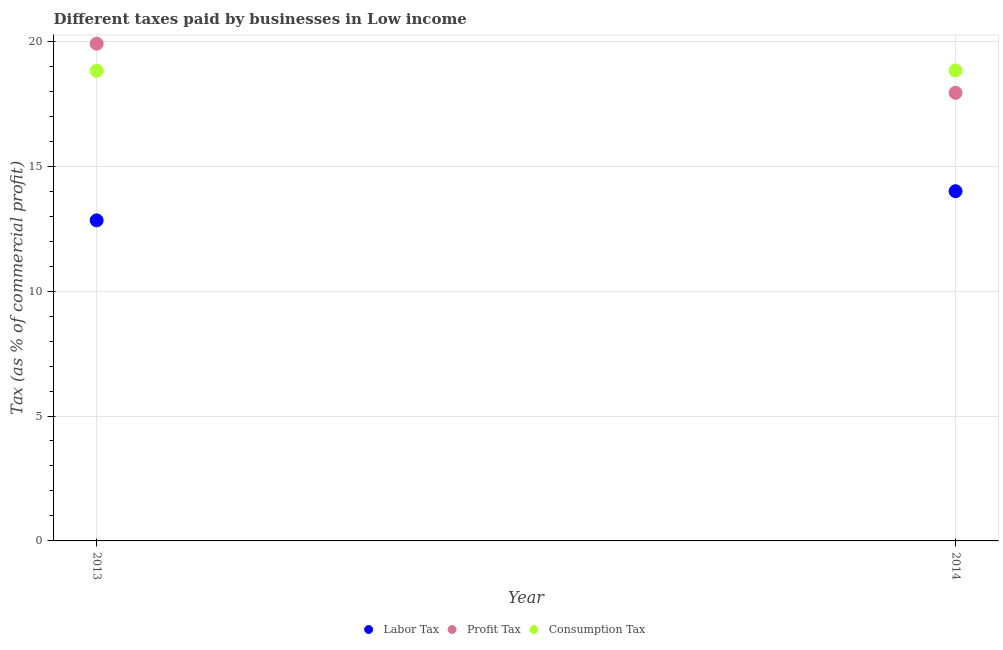How many different coloured dotlines are there?
Your answer should be very brief. 3. Is the number of dotlines equal to the number of legend labels?
Your answer should be very brief. Yes. What is the percentage of consumption tax in 2013?
Your answer should be very brief. 18.82. Across all years, what is the maximum percentage of profit tax?
Provide a succinct answer. 19.9. Across all years, what is the minimum percentage of profit tax?
Your response must be concise. 17.94. In which year was the percentage of labor tax maximum?
Your answer should be compact. 2014. What is the total percentage of labor tax in the graph?
Provide a succinct answer. 26.83. What is the difference between the percentage of consumption tax in 2013 and that in 2014?
Your answer should be very brief. -0.01. What is the difference between the percentage of consumption tax in 2014 and the percentage of profit tax in 2013?
Provide a succinct answer. -1.07. What is the average percentage of consumption tax per year?
Offer a terse response. 18.83. In the year 2014, what is the difference between the percentage of profit tax and percentage of labor tax?
Your answer should be very brief. 3.94. What is the ratio of the percentage of labor tax in 2013 to that in 2014?
Make the answer very short. 0.92. Does the percentage of labor tax monotonically increase over the years?
Offer a terse response. Yes. Is the percentage of profit tax strictly greater than the percentage of labor tax over the years?
Your response must be concise. Yes. How many years are there in the graph?
Provide a succinct answer. 2. What is the difference between two consecutive major ticks on the Y-axis?
Give a very brief answer. 5. Does the graph contain any zero values?
Your response must be concise. No. Where does the legend appear in the graph?
Provide a succinct answer. Bottom center. What is the title of the graph?
Offer a very short reply. Different taxes paid by businesses in Low income. What is the label or title of the Y-axis?
Offer a terse response. Tax (as % of commercial profit). What is the Tax (as % of commercial profit) in Labor Tax in 2013?
Provide a succinct answer. 12.83. What is the Tax (as % of commercial profit) in Profit Tax in 2013?
Provide a succinct answer. 19.9. What is the Tax (as % of commercial profit) in Consumption Tax in 2013?
Provide a succinct answer. 18.82. What is the Tax (as % of commercial profit) of Profit Tax in 2014?
Give a very brief answer. 17.94. What is the Tax (as % of commercial profit) of Consumption Tax in 2014?
Provide a short and direct response. 18.83. Across all years, what is the maximum Tax (as % of commercial profit) of Profit Tax?
Provide a short and direct response. 19.9. Across all years, what is the maximum Tax (as % of commercial profit) in Consumption Tax?
Make the answer very short. 18.83. Across all years, what is the minimum Tax (as % of commercial profit) of Labor Tax?
Make the answer very short. 12.83. Across all years, what is the minimum Tax (as % of commercial profit) of Profit Tax?
Your answer should be compact. 17.94. Across all years, what is the minimum Tax (as % of commercial profit) of Consumption Tax?
Your answer should be very brief. 18.82. What is the total Tax (as % of commercial profit) of Labor Tax in the graph?
Give a very brief answer. 26.83. What is the total Tax (as % of commercial profit) of Profit Tax in the graph?
Provide a short and direct response. 37.84. What is the total Tax (as % of commercial profit) in Consumption Tax in the graph?
Ensure brevity in your answer.  37.66. What is the difference between the Tax (as % of commercial profit) in Labor Tax in 2013 and that in 2014?
Your response must be concise. -1.17. What is the difference between the Tax (as % of commercial profit) of Profit Tax in 2013 and that in 2014?
Offer a very short reply. 1.97. What is the difference between the Tax (as % of commercial profit) of Consumption Tax in 2013 and that in 2014?
Give a very brief answer. -0.01. What is the difference between the Tax (as % of commercial profit) of Labor Tax in 2013 and the Tax (as % of commercial profit) of Profit Tax in 2014?
Your answer should be compact. -5.11. What is the difference between the Tax (as % of commercial profit) of Labor Tax in 2013 and the Tax (as % of commercial profit) of Consumption Tax in 2014?
Offer a very short reply. -6. What is the difference between the Tax (as % of commercial profit) of Profit Tax in 2013 and the Tax (as % of commercial profit) of Consumption Tax in 2014?
Your answer should be very brief. 1.07. What is the average Tax (as % of commercial profit) in Labor Tax per year?
Provide a short and direct response. 13.42. What is the average Tax (as % of commercial profit) in Profit Tax per year?
Provide a short and direct response. 18.92. What is the average Tax (as % of commercial profit) of Consumption Tax per year?
Provide a succinct answer. 18.83. In the year 2013, what is the difference between the Tax (as % of commercial profit) of Labor Tax and Tax (as % of commercial profit) of Profit Tax?
Offer a terse response. -7.07. In the year 2013, what is the difference between the Tax (as % of commercial profit) of Labor Tax and Tax (as % of commercial profit) of Consumption Tax?
Offer a terse response. -5.99. In the year 2013, what is the difference between the Tax (as % of commercial profit) in Profit Tax and Tax (as % of commercial profit) in Consumption Tax?
Give a very brief answer. 1.08. In the year 2014, what is the difference between the Tax (as % of commercial profit) in Labor Tax and Tax (as % of commercial profit) in Profit Tax?
Keep it short and to the point. -3.94. In the year 2014, what is the difference between the Tax (as % of commercial profit) of Labor Tax and Tax (as % of commercial profit) of Consumption Tax?
Keep it short and to the point. -4.83. In the year 2014, what is the difference between the Tax (as % of commercial profit) in Profit Tax and Tax (as % of commercial profit) in Consumption Tax?
Keep it short and to the point. -0.9. What is the ratio of the Tax (as % of commercial profit) in Labor Tax in 2013 to that in 2014?
Ensure brevity in your answer.  0.92. What is the ratio of the Tax (as % of commercial profit) in Profit Tax in 2013 to that in 2014?
Provide a succinct answer. 1.11. What is the ratio of the Tax (as % of commercial profit) in Consumption Tax in 2013 to that in 2014?
Provide a short and direct response. 1. What is the difference between the highest and the second highest Tax (as % of commercial profit) in Labor Tax?
Make the answer very short. 1.17. What is the difference between the highest and the second highest Tax (as % of commercial profit) in Profit Tax?
Ensure brevity in your answer.  1.97. What is the difference between the highest and the second highest Tax (as % of commercial profit) of Consumption Tax?
Make the answer very short. 0.01. What is the difference between the highest and the lowest Tax (as % of commercial profit) of Labor Tax?
Provide a succinct answer. 1.17. What is the difference between the highest and the lowest Tax (as % of commercial profit) of Profit Tax?
Your response must be concise. 1.97. What is the difference between the highest and the lowest Tax (as % of commercial profit) in Consumption Tax?
Offer a terse response. 0.01. 